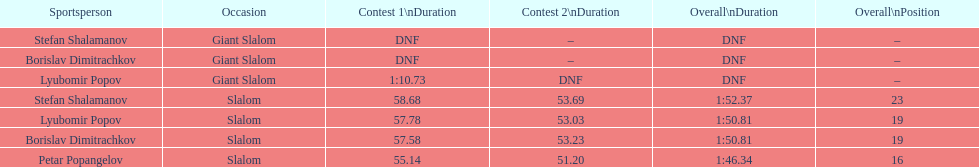Who was the other athlete who tied in rank with lyubomir popov? Borislav Dimitrachkov. 